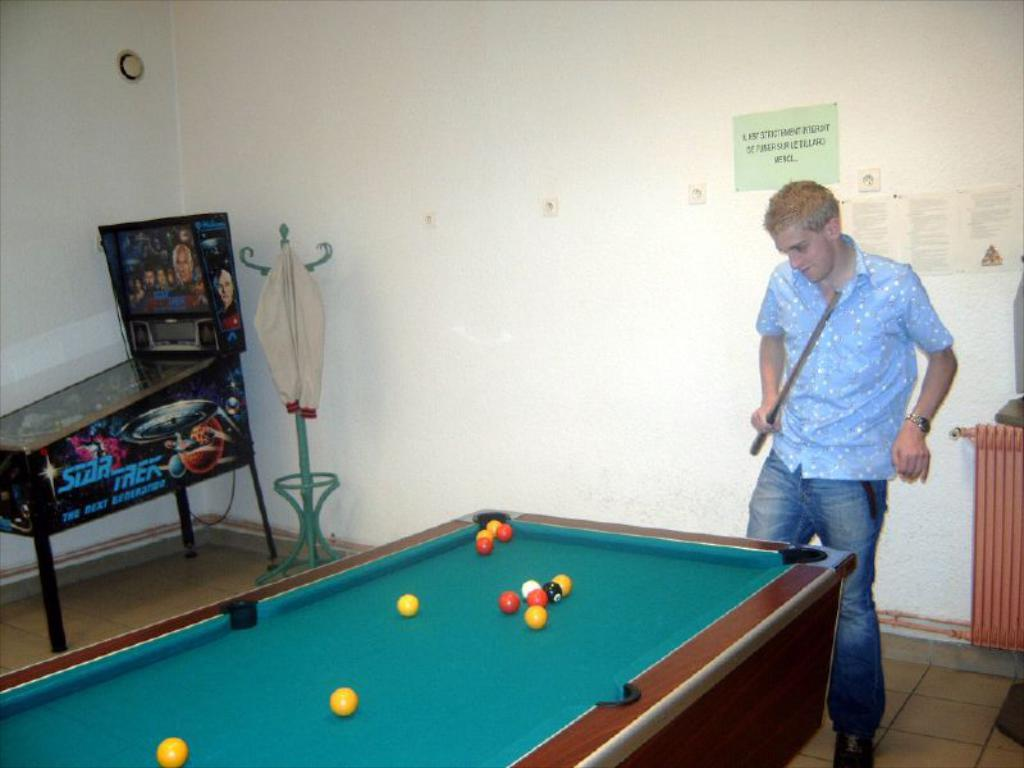Who is present in the image? There is a man in the image. What is the man doing in the image? The man is playing a snookers game near a snooker board. What can be seen in the background of the image? There is a game and a poster on the wall in the background of the image. How does the man use a wrench to improve his snookers game in the image? There is no wrench present in the image, and the man is not using any tools to improve his game. 